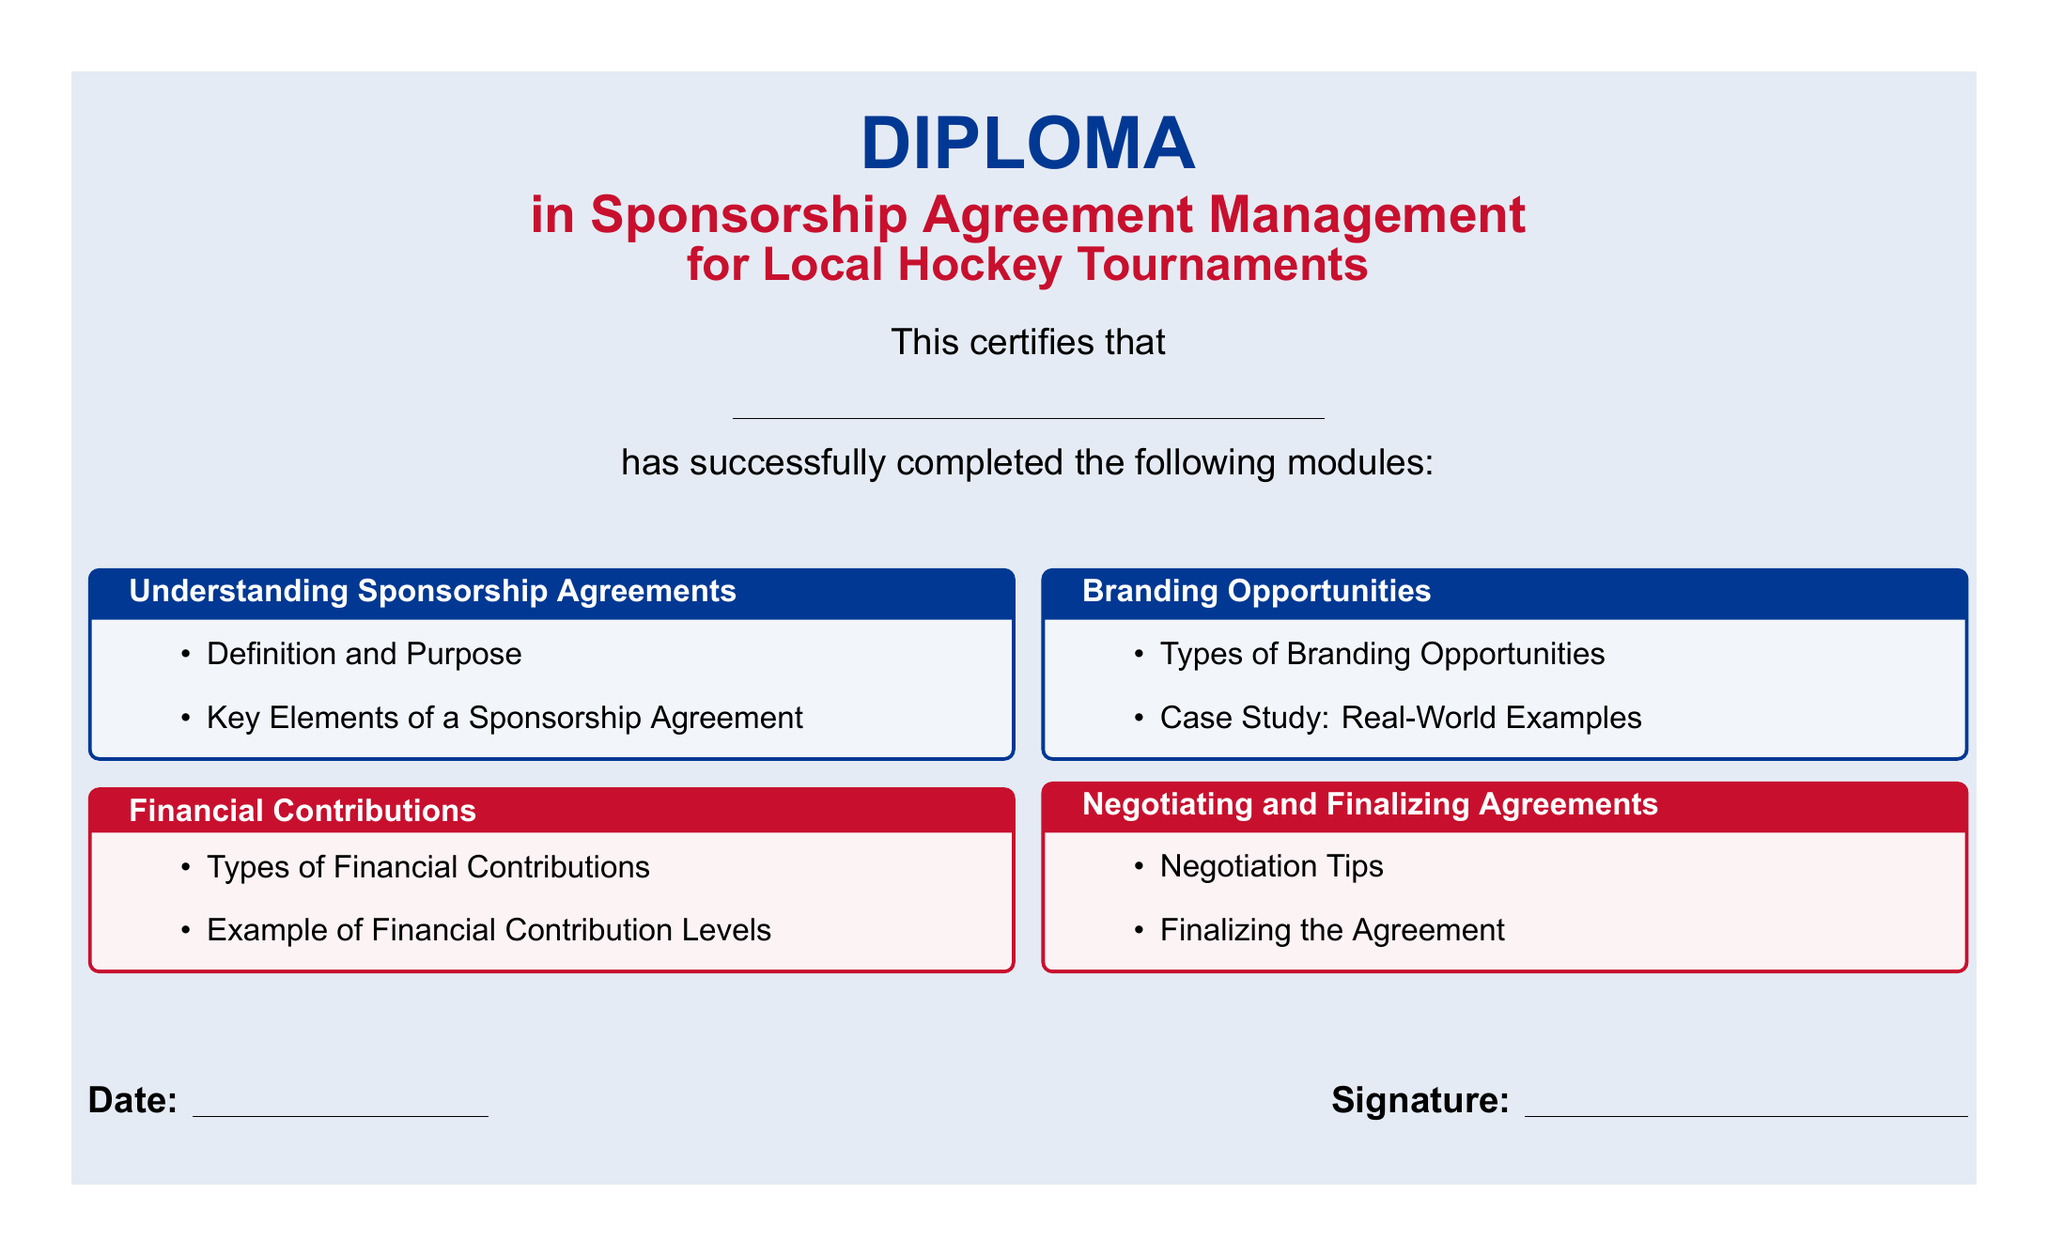What is the title of the diploma? The title can be found prominently displayed at the top of the document.
Answer: Diploma in Sponsorship Agreement Management Who completed the diploma? This section is intended for the name of the individual who completed the program, typically left blank for filling out.
Answer: \underline{\hspace{8cm}} How many modules were completed? The document lists the different modules that were part of the diploma program.
Answer: Four What is one type of financial contribution mentioned? The document indicates a section specifically about financial contributions and includes multiple types.
Answer: Types of Financial Contributions What color is used for the diploma's background? The document has a specified background color for certain sections defined in the code.
Answer: White What are the branding opportunities related to? The document explicitly states the focus of one of its modules about branding opportunities.
Answer: Types of Branding Opportunities What is a key activity mentioned for finalizing agreements? The finalizing agreement module includes tips that facilitate the concluding processes in sponsorships.
Answer: Finalizing the Agreement Which two colors are prominently featured in the diploma? The document specifies two key colors used throughout its layout for distinct areas.
Answer: Hockey blue and Hockey red What is the purpose of this diploma? The introductory text provides the primary function or objective of the diploma.
Answer: Sponsorship Agreement Management 